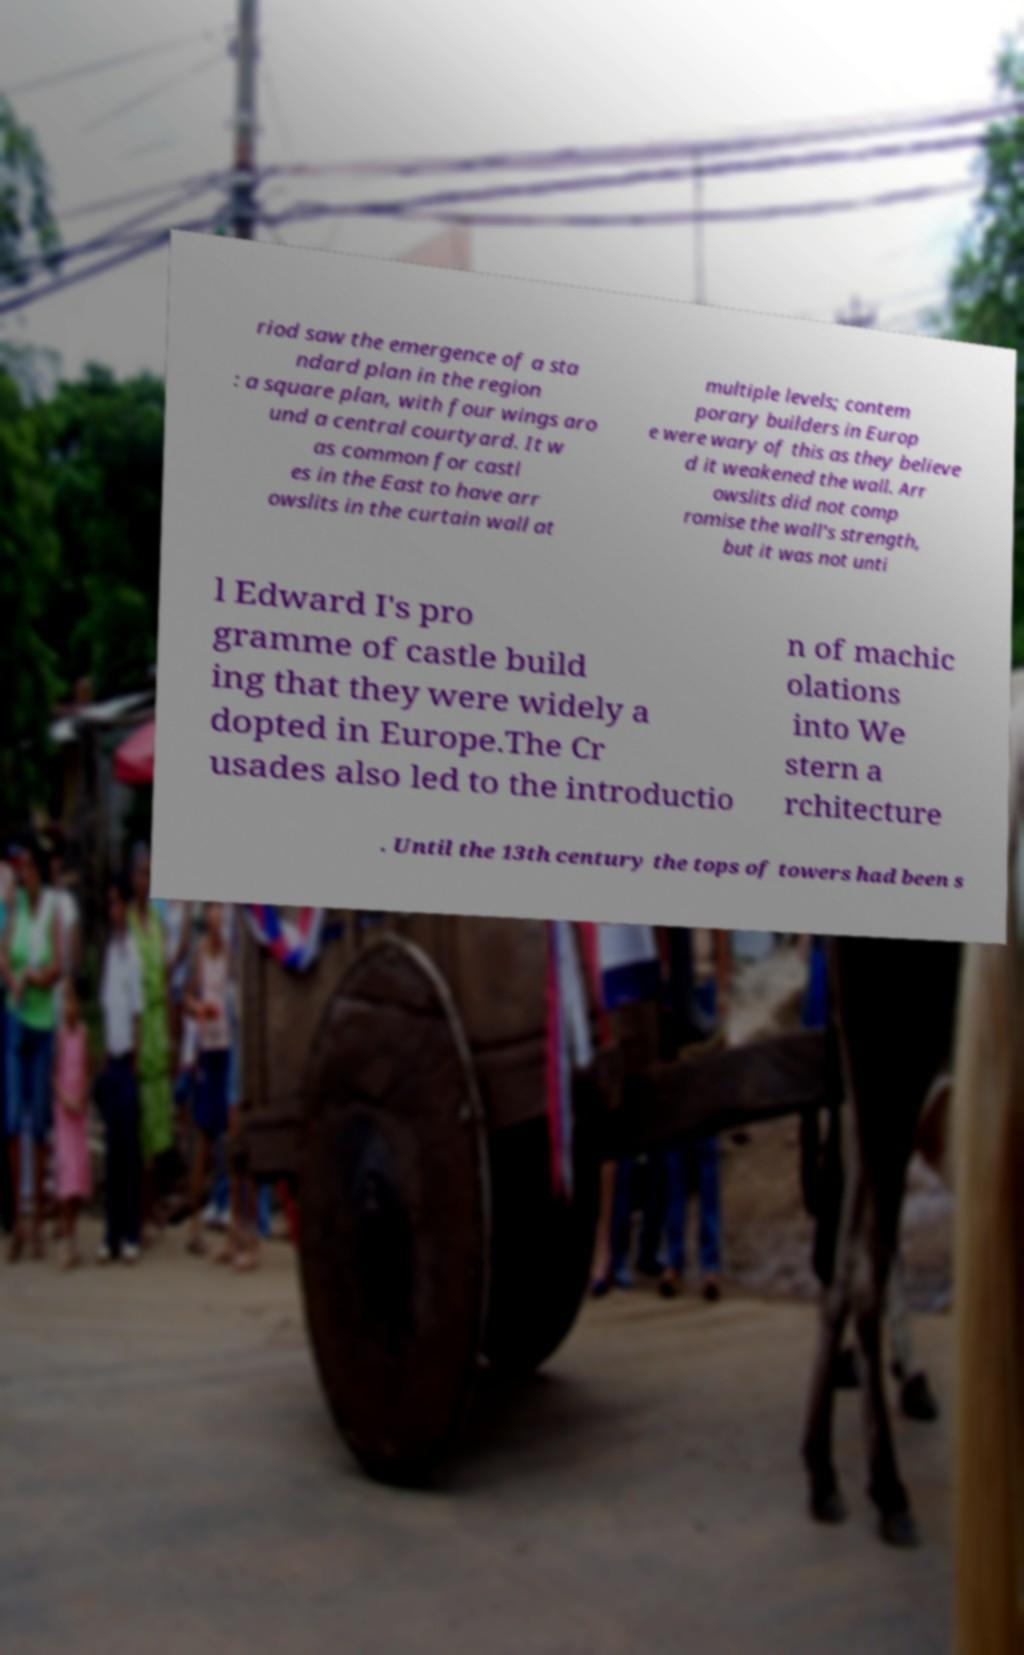I need the written content from this picture converted into text. Can you do that? riod saw the emergence of a sta ndard plan in the region : a square plan, with four wings aro und a central courtyard. It w as common for castl es in the East to have arr owslits in the curtain wall at multiple levels; contem porary builders in Europ e were wary of this as they believe d it weakened the wall. Arr owslits did not comp romise the wall's strength, but it was not unti l Edward I's pro gramme of castle build ing that they were widely a dopted in Europe.The Cr usades also led to the introductio n of machic olations into We stern a rchitecture . Until the 13th century the tops of towers had been s 